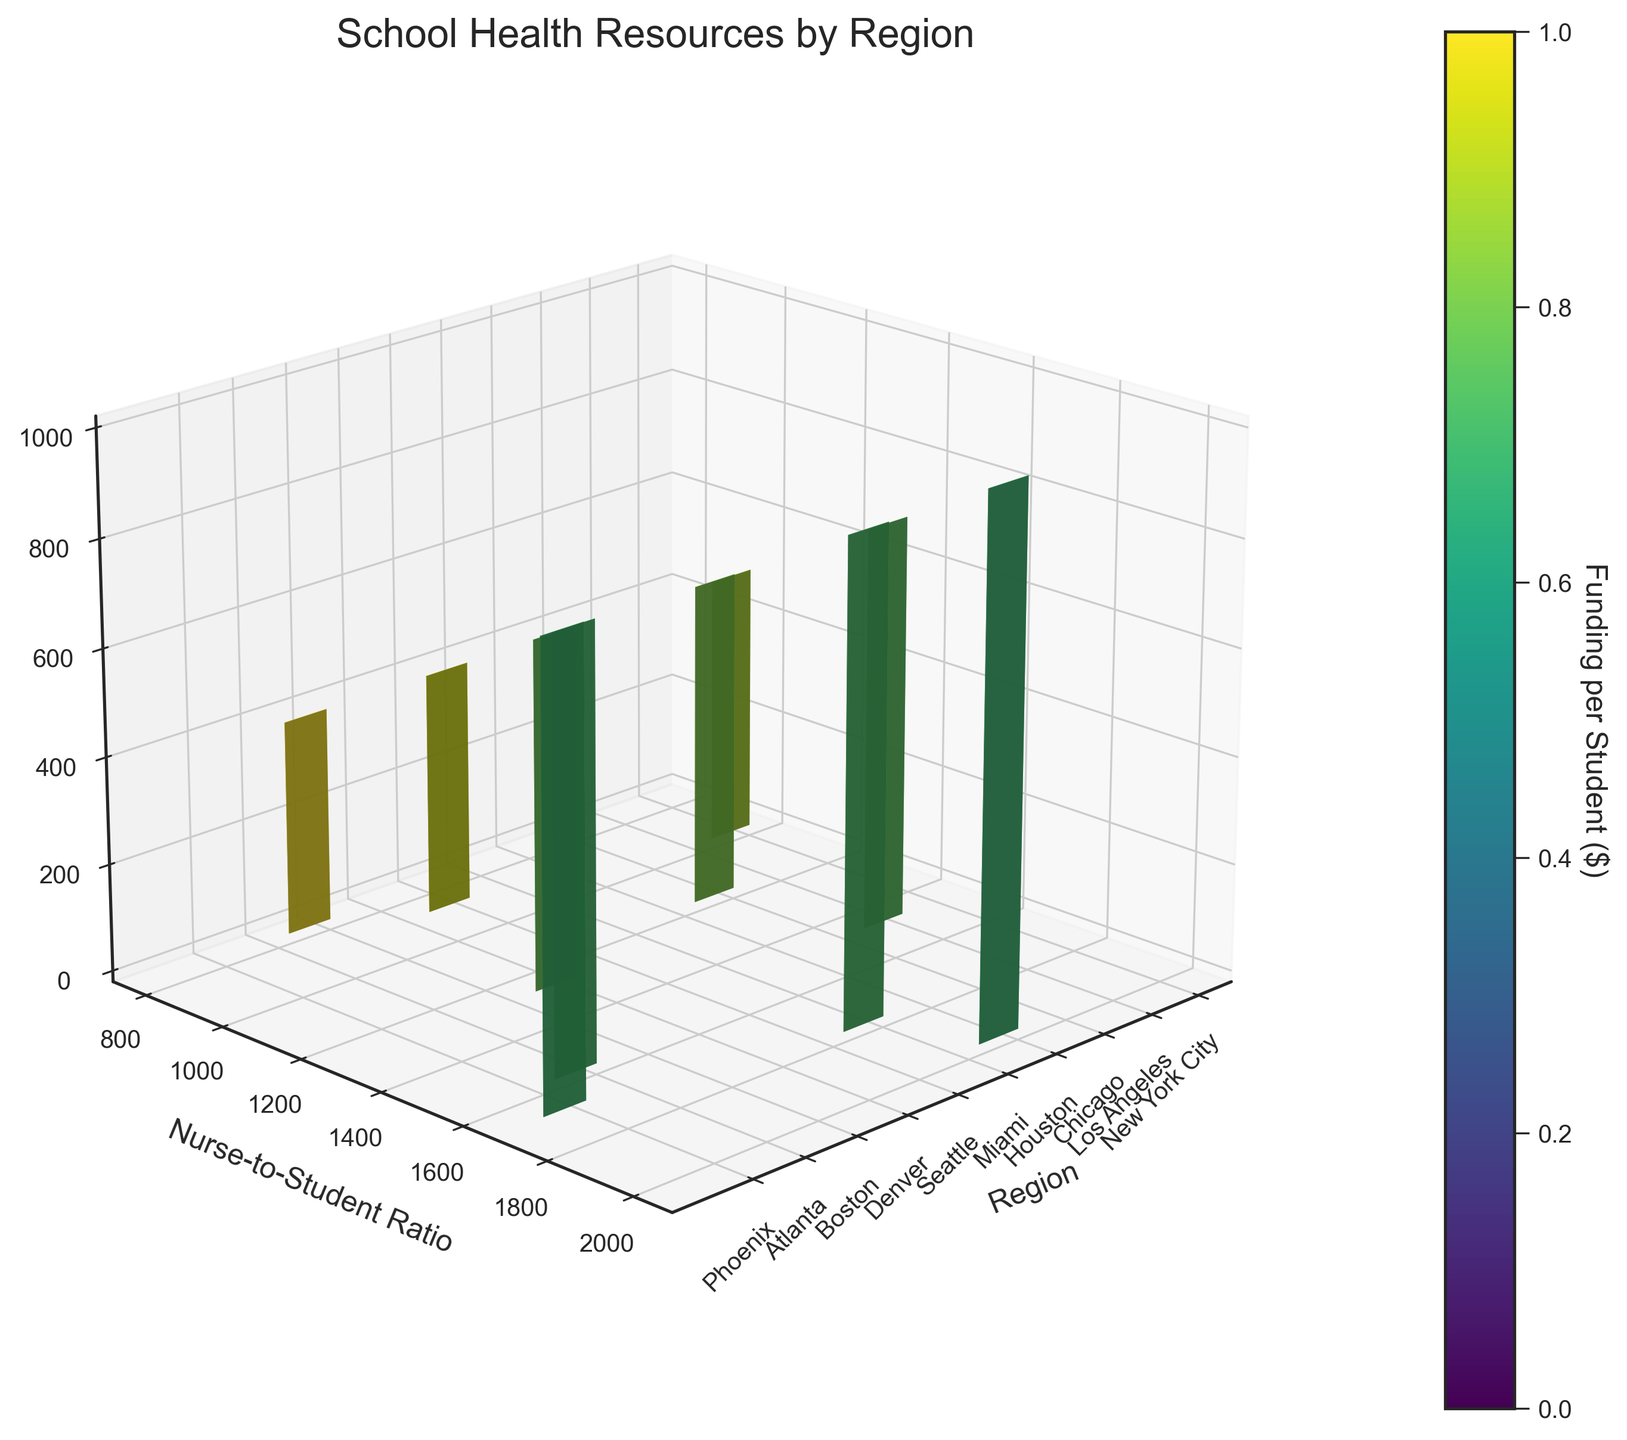What's the title of the figure? The title of the figure is typically displayed at the top. By glancing at the top portion of the figure, one can find the title.
Answer: School Health Resources by Region What is the nurse-to-student ratio for Boston? To find the nurse-to-student ratio for Boston, locate the region labeled "Boston" on the x-axis and then look at the corresponding y-axis value.
Answer: 1:800 Which region has the highest funding per student? The figure includes a color bar indicating the funding per student. The darkest hue (typically toward the higher end of the color spectrum) corresponds to the region with the highest funding per student. By identifying the darkest bar, we can pinpoint the region.
Answer: Boston How does the nurse-to-student ratio in New York City compare to that in Houston? First, locate the nurse-to-student ratio for New York City and Houston on the y-axis. Comparing these two values will show which has a higher or lower ratio. New York City's ratio is 1:1000, while Houston's is 1:2000.
Answer: New York City has a lower nurse-to-student ratio than Houston What does the color of the 3D blocks represent in the figure? The color of the 3D blocks signifies the funding per student. This is indicated by the color bar on the side of the figure.
Answer: Funding per student Which region has the lowest nurse-to-student ratio? To determine the lowest nurse-to-student ratio, locate the region with the smallest y-axis value.
Answer: Boston Which region has a similar mental health staff ratio to Seattle? By comparing the mental health staff ratio values on the z-axis, identify the region with a value close to Seattle's, which is 1:450. Boston has a mental health staff ratio of 1:400, which is the closest.
Answer: Boston What can you say about the funding per student when comparing Miami and Phoenix? By comparing the colors of the 3D blocks for Miami and Phoenix, we can determine which has more funding per student. The color closer to the higher end of the color bar represents higher funding.
Answer: Miami has higher funding per student than Phoenix What region has a nurse-to-student ratio of approximately 1:1200 and funding per student around $325? Identify the region meeting these criteria by locating the specific nurse-to-student ratio on the y-axis and corresponding approximate funding on the color bar.
Answer: Chicago 